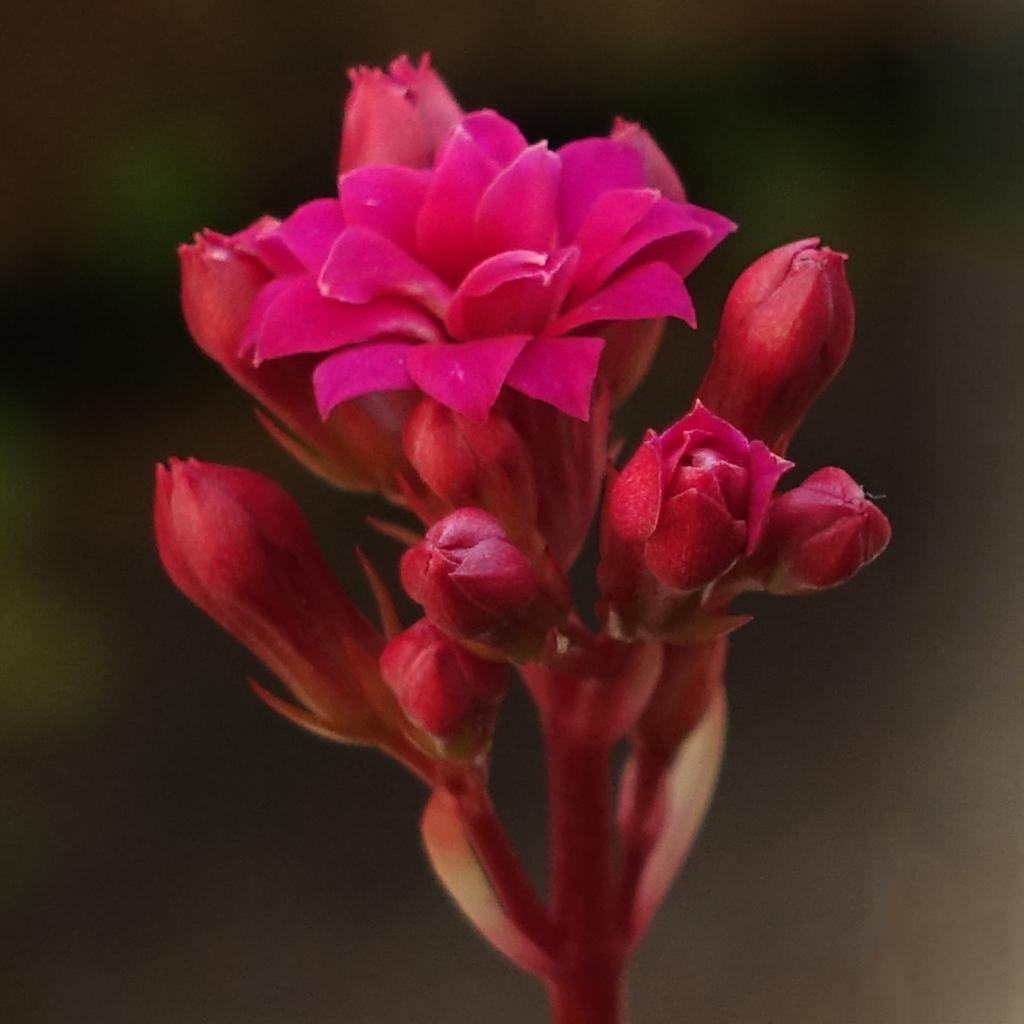What is the main subject of the picture? The main subject of the picture is a flower. Are there any other parts of the flower visible in the image? Yes, there are buds in the picture. How would you describe the background of the image? The background of the image is blurry. How many bridges can be seen crossing the river in the image? There are no bridges or rivers present in the image; it features a flower and buds. What type of flower is shown growing out of the part in the image? There is no specific type of flower mentioned, and the term "part" is not relevant to the image, as it only features a flower and buds. 